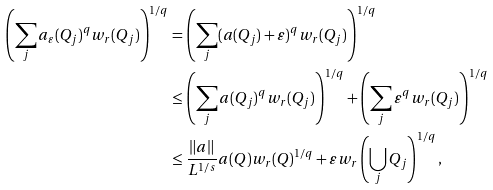<formula> <loc_0><loc_0><loc_500><loc_500>\left ( \sum _ { j } a _ { \varepsilon } ( Q _ { j } ) ^ { q } w _ { r } ( Q _ { j } ) \right ) ^ { 1 / q } & = \left ( \sum _ { j } ( a ( Q _ { j } ) + \varepsilon ) ^ { q } w _ { r } ( Q _ { j } ) \right ) ^ { 1 / q } \\ & \leq \left ( \sum _ { j } a ( Q _ { j } ) ^ { q } w _ { r } ( Q _ { j } ) \right ) ^ { 1 / q } + \left ( \sum _ { j } \varepsilon ^ { q } w _ { r } ( Q _ { j } ) \right ) ^ { 1 / q } \\ & \leq \frac { \| a \| } { L ^ { 1 / s } } a ( Q ) w _ { r } ( Q ) ^ { 1 / q } + \varepsilon w _ { r } \left ( \bigcup _ { j } Q _ { j } \right ) ^ { 1 / q } ,</formula> 